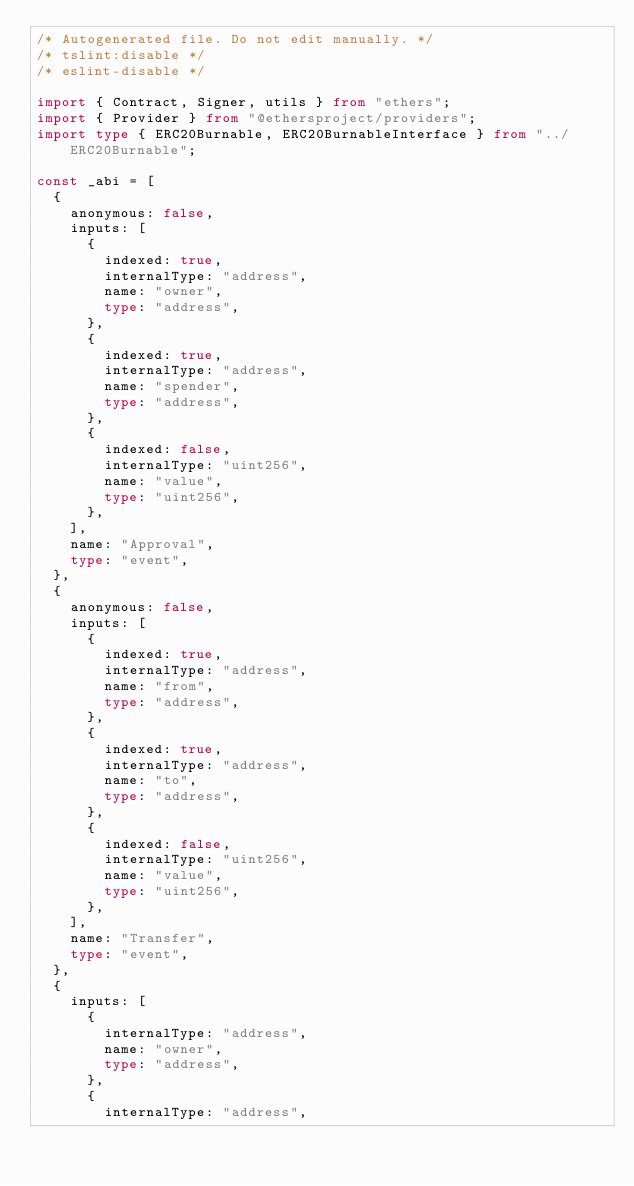<code> <loc_0><loc_0><loc_500><loc_500><_TypeScript_>/* Autogenerated file. Do not edit manually. */
/* tslint:disable */
/* eslint-disable */

import { Contract, Signer, utils } from "ethers";
import { Provider } from "@ethersproject/providers";
import type { ERC20Burnable, ERC20BurnableInterface } from "../ERC20Burnable";

const _abi = [
  {
    anonymous: false,
    inputs: [
      {
        indexed: true,
        internalType: "address",
        name: "owner",
        type: "address",
      },
      {
        indexed: true,
        internalType: "address",
        name: "spender",
        type: "address",
      },
      {
        indexed: false,
        internalType: "uint256",
        name: "value",
        type: "uint256",
      },
    ],
    name: "Approval",
    type: "event",
  },
  {
    anonymous: false,
    inputs: [
      {
        indexed: true,
        internalType: "address",
        name: "from",
        type: "address",
      },
      {
        indexed: true,
        internalType: "address",
        name: "to",
        type: "address",
      },
      {
        indexed: false,
        internalType: "uint256",
        name: "value",
        type: "uint256",
      },
    ],
    name: "Transfer",
    type: "event",
  },
  {
    inputs: [
      {
        internalType: "address",
        name: "owner",
        type: "address",
      },
      {
        internalType: "address",</code> 